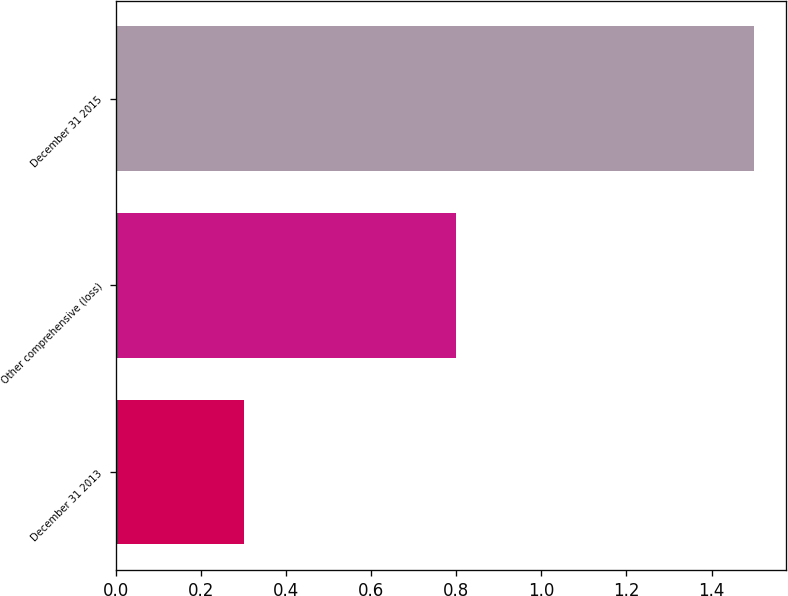Convert chart to OTSL. <chart><loc_0><loc_0><loc_500><loc_500><bar_chart><fcel>December 31 2013<fcel>Other comprehensive (loss)<fcel>December 31 2015<nl><fcel>0.3<fcel>0.8<fcel>1.5<nl></chart> 